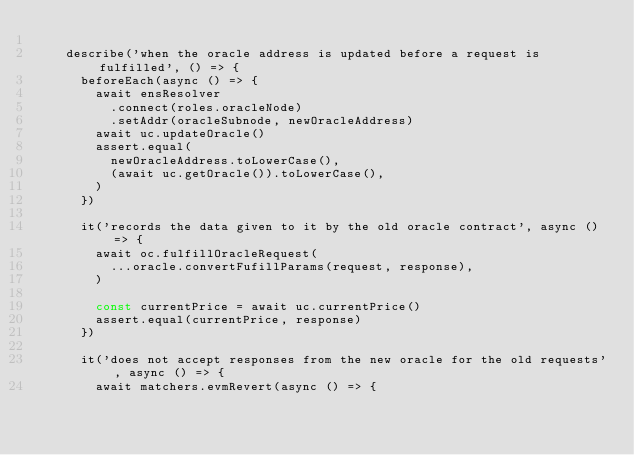Convert code to text. <code><loc_0><loc_0><loc_500><loc_500><_TypeScript_>
    describe('when the oracle address is updated before a request is fulfilled', () => {
      beforeEach(async () => {
        await ensResolver
          .connect(roles.oracleNode)
          .setAddr(oracleSubnode, newOracleAddress)
        await uc.updateOracle()
        assert.equal(
          newOracleAddress.toLowerCase(),
          (await uc.getOracle()).toLowerCase(),
        )
      })

      it('records the data given to it by the old oracle contract', async () => {
        await oc.fulfillOracleRequest(
          ...oracle.convertFufillParams(request, response),
        )

        const currentPrice = await uc.currentPrice()
        assert.equal(currentPrice, response)
      })

      it('does not accept responses from the new oracle for the old requests', async () => {
        await matchers.evmRevert(async () => {</code> 